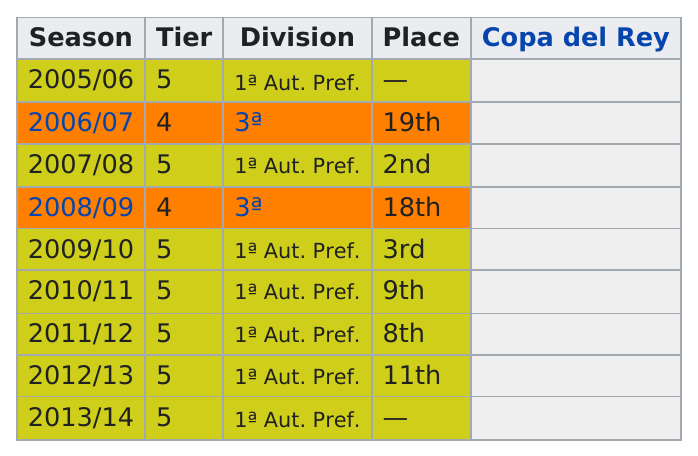Mention a couple of crucial points in this snapshot. In my opinion, 2006/07 was a better season than 2005/06. The lowest tier for season-to-season is 4. After the 2005/2006 season, the total amount of 5-tier tickets sold was X. When was the only 8th place? It was in the 2011/2012 season. This team has been a part of the first-tiered aut. pref. division for 7 years. 